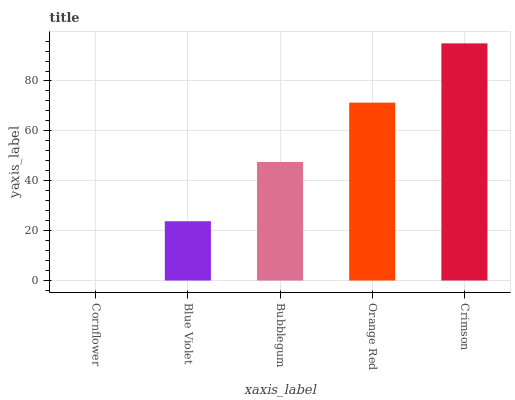Is Cornflower the minimum?
Answer yes or no. Yes. Is Crimson the maximum?
Answer yes or no. Yes. Is Blue Violet the minimum?
Answer yes or no. No. Is Blue Violet the maximum?
Answer yes or no. No. Is Blue Violet greater than Cornflower?
Answer yes or no. Yes. Is Cornflower less than Blue Violet?
Answer yes or no. Yes. Is Cornflower greater than Blue Violet?
Answer yes or no. No. Is Blue Violet less than Cornflower?
Answer yes or no. No. Is Bubblegum the high median?
Answer yes or no. Yes. Is Bubblegum the low median?
Answer yes or no. Yes. Is Crimson the high median?
Answer yes or no. No. Is Crimson the low median?
Answer yes or no. No. 